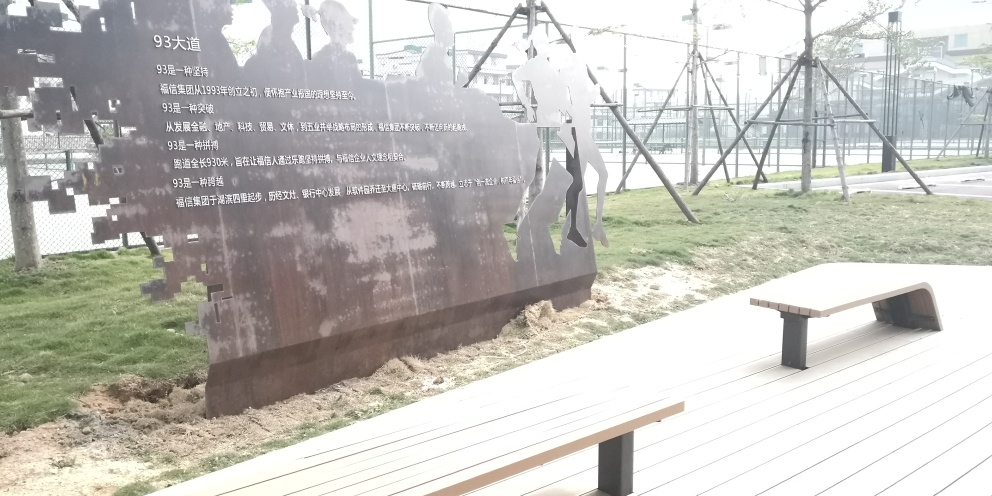How would you describe the overall quality of the photo? The photo is of moderate quality. It appears to be taken during the daytime with adequate natural lighting, though it suffers from some overexposure in the background, which affects the visibility of details in that area. The focal point of the metal silhouettes is clear, and the composition is balanced with a bench in the foreground; however, the overall sharpness and resolution could be improved. 